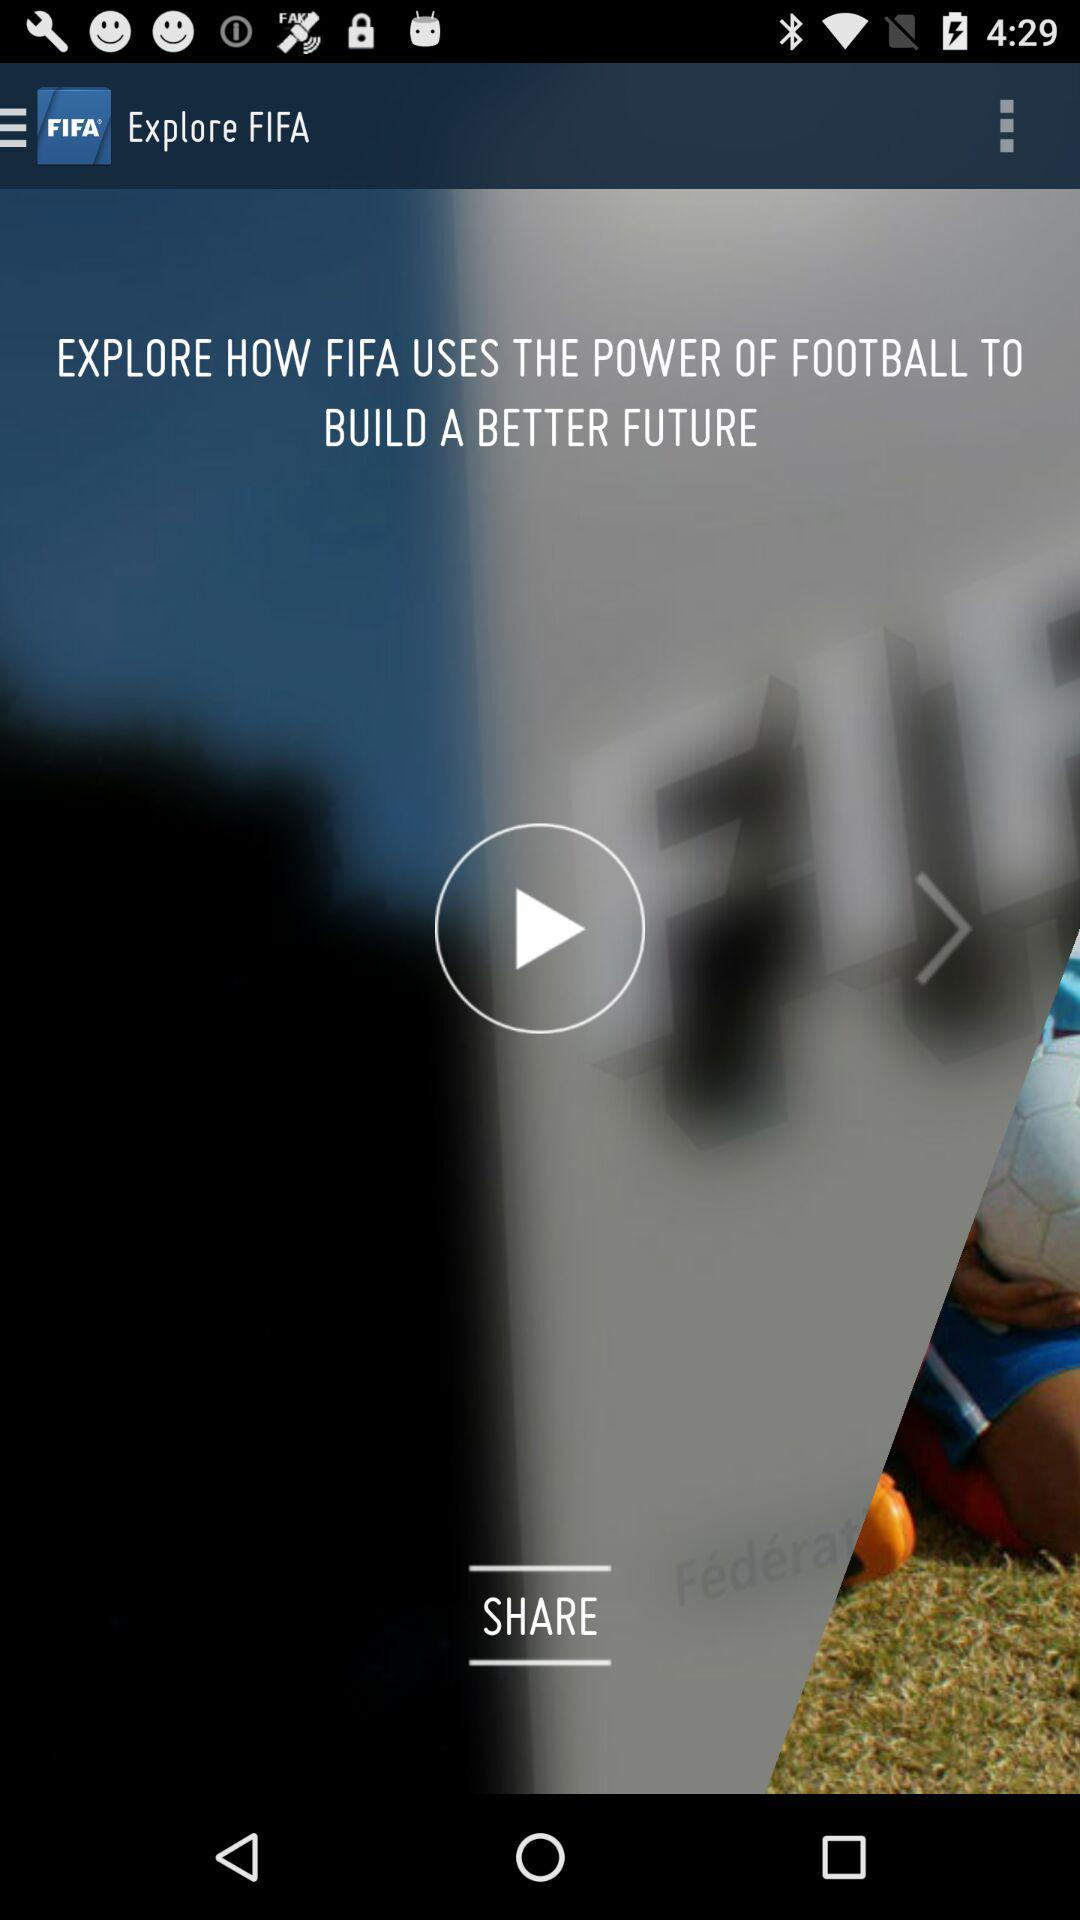What is the app name? The app name is "FIFA". 